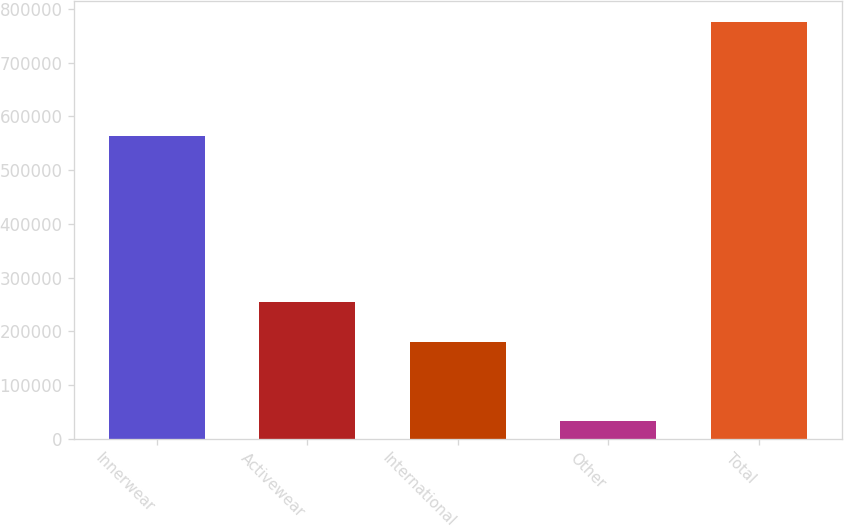Convert chart. <chart><loc_0><loc_0><loc_500><loc_500><bar_chart><fcel>Innerwear<fcel>Activewear<fcel>International<fcel>Other<fcel>Total<nl><fcel>563905<fcel>254202<fcel>179917<fcel>32801<fcel>775649<nl></chart> 